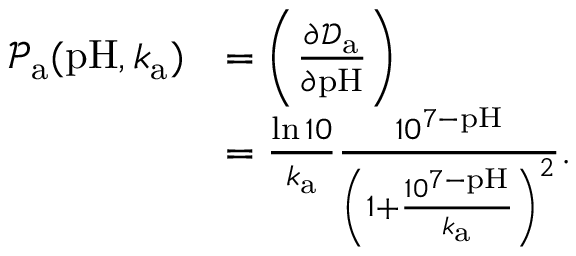<formula> <loc_0><loc_0><loc_500><loc_500>\begin{array} { r l } { \mathcal { P } _ { a } ( p H , k _ { a } ) } & { = \left ( \frac { \partial \mathcal { D } _ { a } } { \partial p H } \right ) } \\ & { = \frac { \ln { 1 0 } } { k _ { a } } \frac { 1 0 ^ { 7 - p H } } { \left ( 1 + \frac { 1 0 ^ { 7 - p H } } { k _ { a } } \right ) ^ { 2 } } . } \end{array}</formula> 